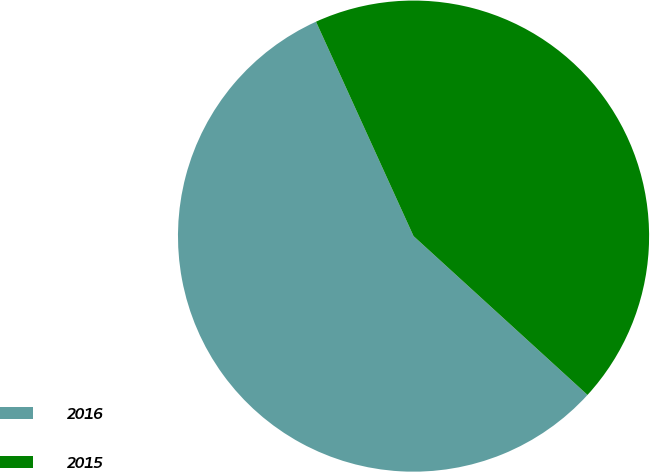Convert chart to OTSL. <chart><loc_0><loc_0><loc_500><loc_500><pie_chart><fcel>2016<fcel>2015<nl><fcel>56.43%<fcel>43.57%<nl></chart> 